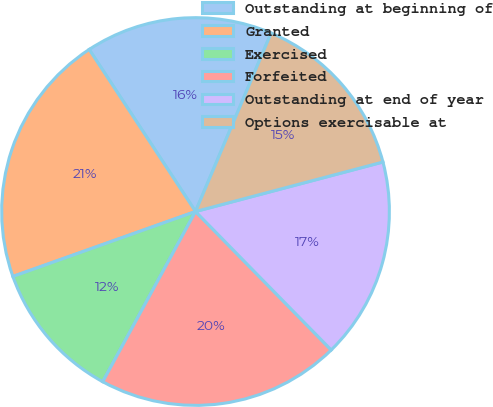Convert chart. <chart><loc_0><loc_0><loc_500><loc_500><pie_chart><fcel>Outstanding at beginning of<fcel>Granted<fcel>Exercised<fcel>Forfeited<fcel>Outstanding at end of year<fcel>Options exercisable at<nl><fcel>15.62%<fcel>21.19%<fcel>11.62%<fcel>20.28%<fcel>16.77%<fcel>14.51%<nl></chart> 